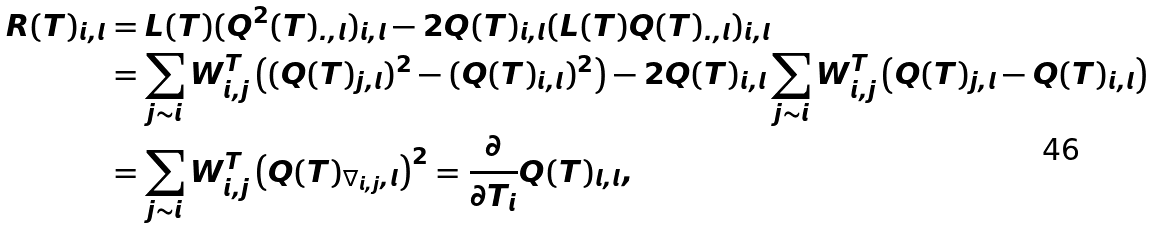<formula> <loc_0><loc_0><loc_500><loc_500>R ( T ) _ { i , l } & = L ( T ) ( Q ^ { 2 } ( T ) _ { . , l } ) _ { i , l } - 2 Q ( T ) _ { i , l } ( L ( T ) Q ( T ) _ { . , l } ) _ { i , l } \\ & = \sum _ { j \sim i } W _ { i , j } ^ { T } \left ( ( Q ( T ) _ { j , l } ) ^ { 2 } - ( Q ( T ) _ { i , l } ) ^ { 2 } \right ) - 2 Q ( T ) _ { i , l } \sum _ { j \sim i } W _ { i , j } ^ { T } \left ( Q ( T ) _ { j , l } - Q ( T ) _ { i , l } \right ) \\ & = \sum _ { j \sim i } W _ { i , j } ^ { T } \left ( Q ( T ) _ { \nabla _ { i , j } , l } \right ) ^ { 2 } = \frac { \partial } { \partial T _ { i } } Q ( T ) _ { l , l } ,</formula> 